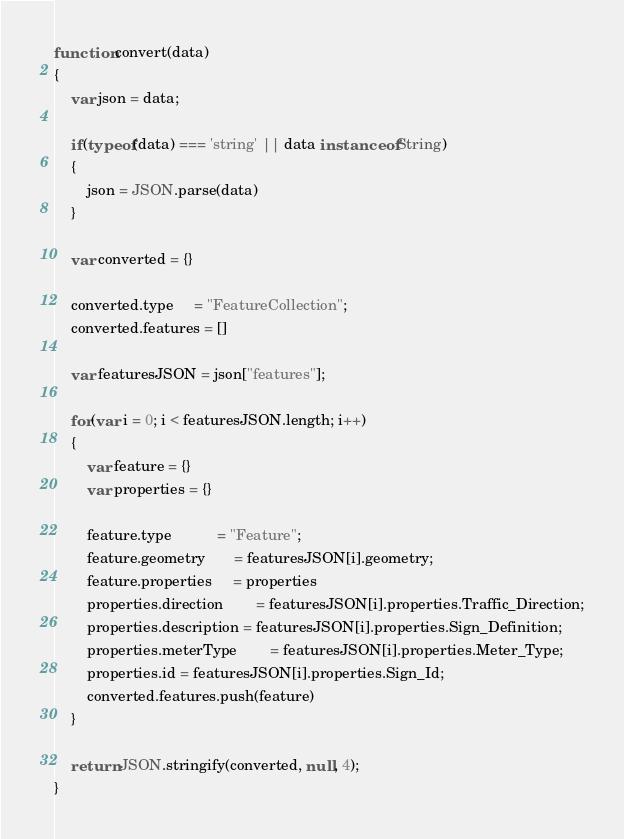Convert code to text. <code><loc_0><loc_0><loc_500><loc_500><_JavaScript_>
function convert(data)
{
    var json = data;

    if(typeof(data) === 'string' || data instanceof String)
    {
        json = JSON.parse(data)
    }

    var converted = {}

    converted.type     = "FeatureCollection";
    converted.features = []

    var featuresJSON = json["features"];

    for(var i = 0; i < featuresJSON.length; i++)
    {
        var feature = {}
        var properties = {}

        feature.type           = "Feature";
        feature.geometry       = featuresJSON[i].geometry;
        feature.properties     = properties
        properties.direction        = featuresJSON[i].properties.Traffic_Direction;
        properties.description = featuresJSON[i].properties.Sign_Definition;
        properties.meterType        = featuresJSON[i].properties.Meter_Type;
        properties.id = featuresJSON[i].properties.Sign_Id;
        converted.features.push(feature)
    }

    return JSON.stringify(converted, null, 4);
}
</code> 